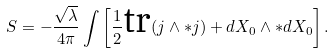Convert formula to latex. <formula><loc_0><loc_0><loc_500><loc_500>S = - \frac { \sqrt { \lambda } } { 4 \pi } \int \left [ \frac { 1 } { 2 } \text {tr} ( j \wedge \ast j ) + d X _ { 0 } \wedge \ast d X _ { 0 } \right ] .</formula> 